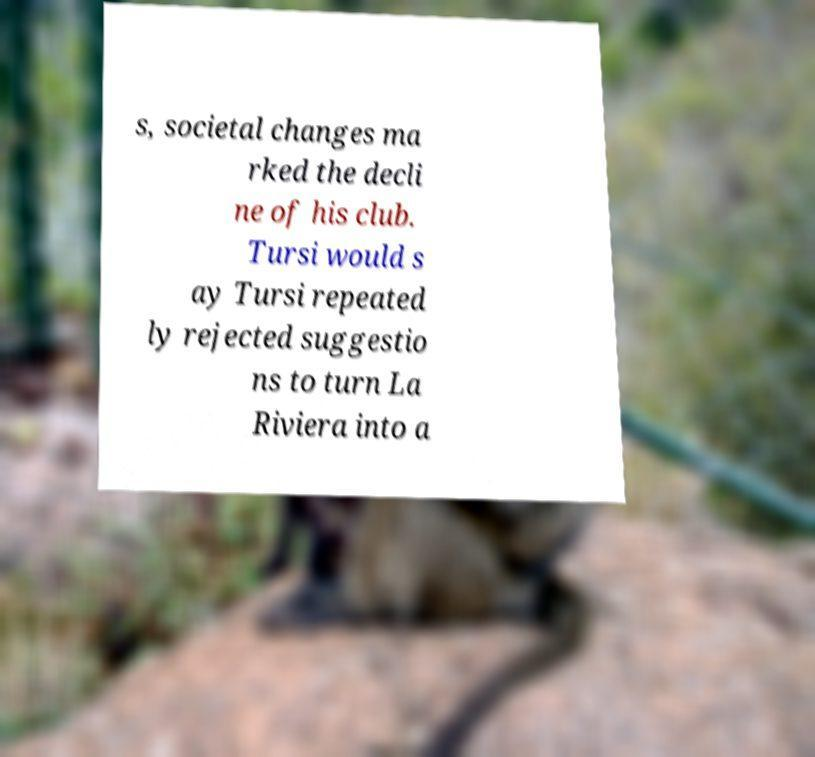Could you assist in decoding the text presented in this image and type it out clearly? s, societal changes ma rked the decli ne of his club. Tursi would s ay Tursi repeated ly rejected suggestio ns to turn La Riviera into a 